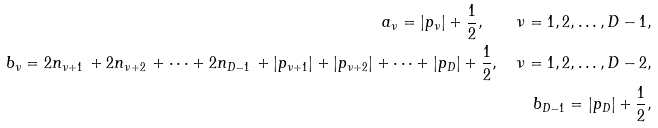<formula> <loc_0><loc_0><loc_500><loc_500>a _ { \nu } = | p _ { \nu } | + \frac { 1 } { 2 } , \quad \nu = 1 , 2 , \dots , D - 1 , \\ b _ { \nu } = 2 n _ { \nu + 1 } \, + 2 n _ { \nu + 2 } \, + \cdots + 2 n _ { D - 1 } \, + | p _ { \nu + 1 } | + | p _ { \nu + 2 } | + \cdots + | p _ { D } | + \frac { 1 } { 2 } , \quad \nu = 1 , 2 , \dots , D - 2 , \\ b _ { D - 1 } = | p _ { D } | + \frac { 1 } { 2 } ,</formula> 